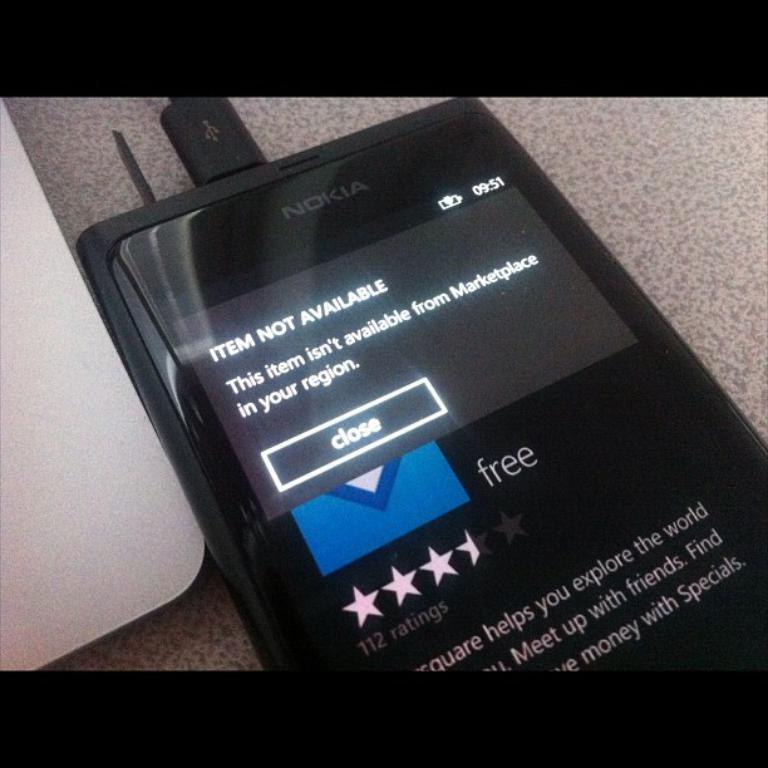What can be seen in the image that is typically used for communication? There is a mobile in the image. What is visible on the mobile's screen? The mobile's screen displays some text. What part of the mobile is used for connecting to other devices? There is a connector associated with the mobile. Can you describe the object on the left side of the image? Unfortunately, the provided facts do not give any information about the object on the left side of the image. What type of story is being told by the monkey in the image? There is no monkey present in the image, so no story can be told by a monkey. 